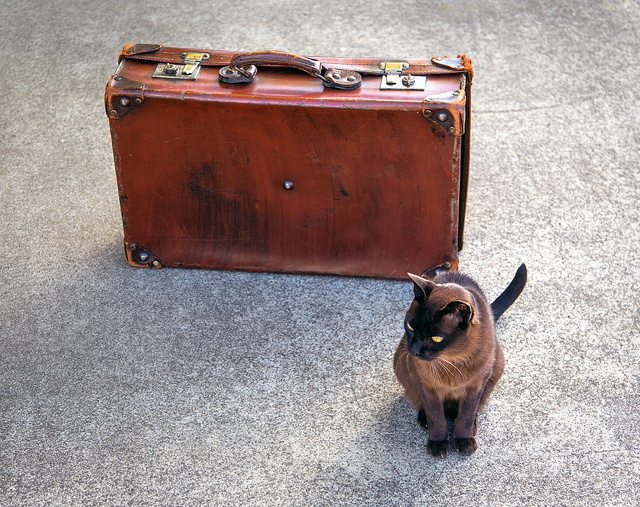Describe the objects in this image and their specific colors. I can see suitcase in gray, maroon, black, and brown tones and cat in gray, black, brown, and maroon tones in this image. 